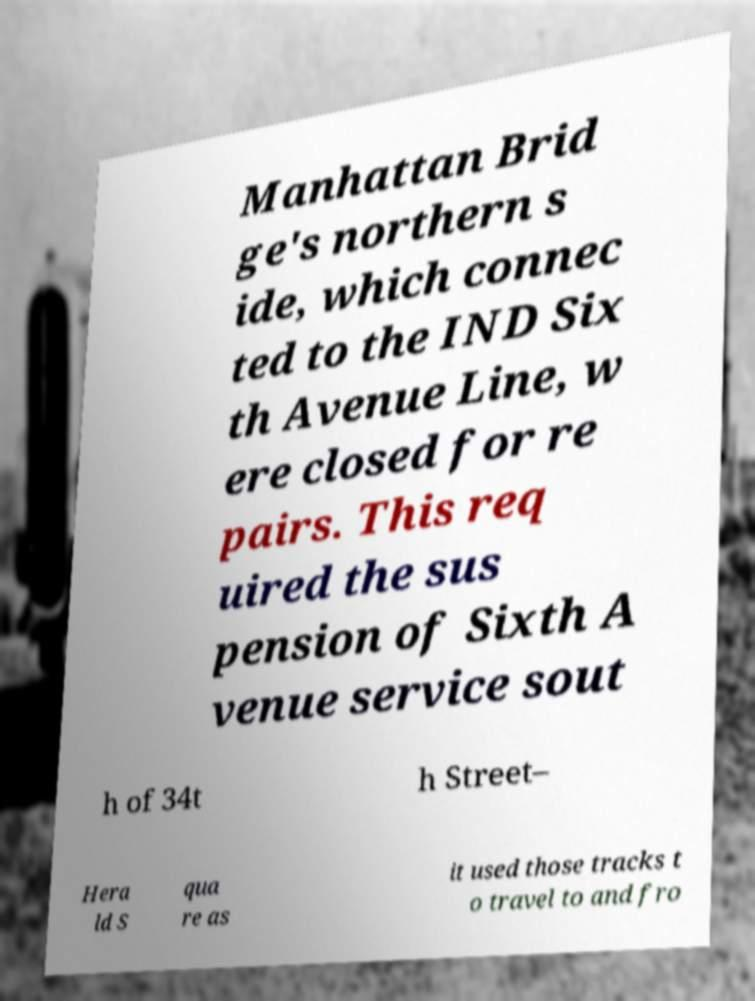Can you read and provide the text displayed in the image?This photo seems to have some interesting text. Can you extract and type it out for me? Manhattan Brid ge's northern s ide, which connec ted to the IND Six th Avenue Line, w ere closed for re pairs. This req uired the sus pension of Sixth A venue service sout h of 34t h Street– Hera ld S qua re as it used those tracks t o travel to and fro 